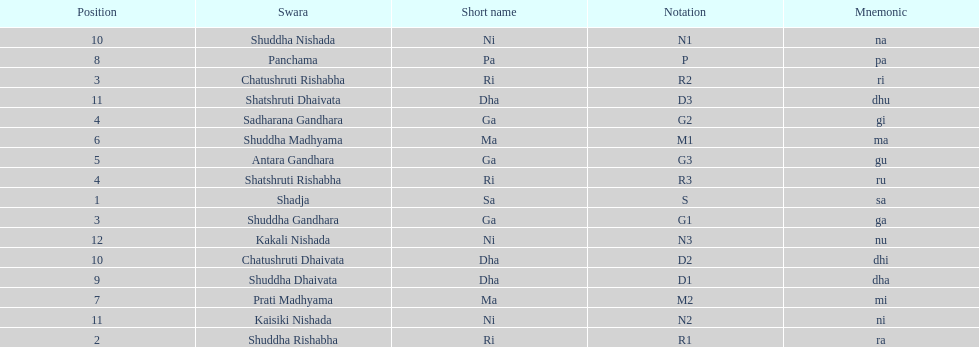What is the name of the swara that comes after panchama? Shuddha Dhaivata. 